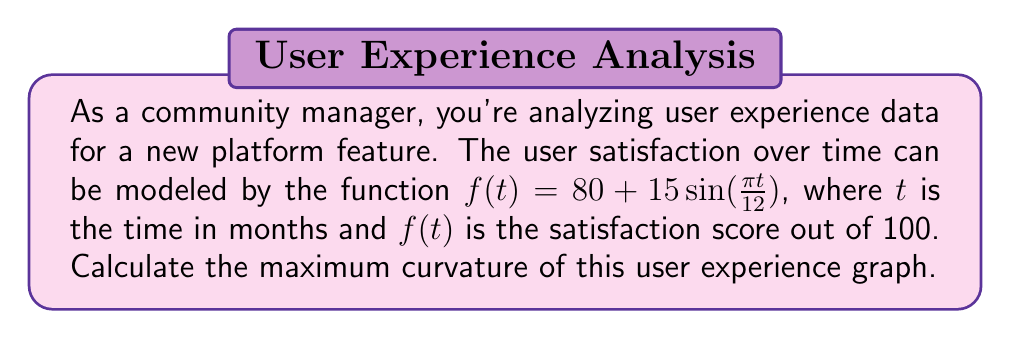What is the answer to this math problem? To find the maximum curvature, we'll follow these steps:

1) The curvature of a function $f(t)$ is given by:

   $$\kappa(t) = \frac{|f''(t)|}{(1 + [f'(t)]^2)^{3/2}}$$

2) Let's find $f'(t)$ and $f''(t)$:
   
   $f'(t) = 15 \cdot \frac{\pi}{12} \cos(\frac{\pi t}{12}) = \frac{5\pi}{4} \cos(\frac{\pi t}{12})$
   
   $f''(t) = -\frac{5\pi}{4} \cdot \frac{\pi}{12} \sin(\frac{\pi t}{12}) = -\frac{5\pi^2}{48} \sin(\frac{\pi t}{12})$

3) Substitute these into the curvature formula:

   $$\kappa(t) = \frac{|\frac{5\pi^2}{48} \sin(\frac{\pi t}{12})|}{\left(1 + [\frac{5\pi}{4} \cos(\frac{\pi t}{12})]^2\right)^{3/2}}$$

4) The maximum curvature will occur when $|\sin(\frac{\pi t}{12})|$ is at its maximum (1) and $\cos(\frac{\pi t}{12})$ is at its minimum (0). This happens when $\frac{\pi t}{12} = \frac{\pi}{2}$ or $\frac{3\pi}{2}$.

5) At these points, the curvature is:

   $$\kappa_{max} = \frac{\frac{5\pi^2}{48}}{(1 + 0)^{3/2}} = \frac{5\pi^2}{48}$$

Therefore, the maximum curvature is $\frac{5\pi^2}{48}$.
Answer: $\frac{5\pi^2}{48}$ or approximately 1.0272 